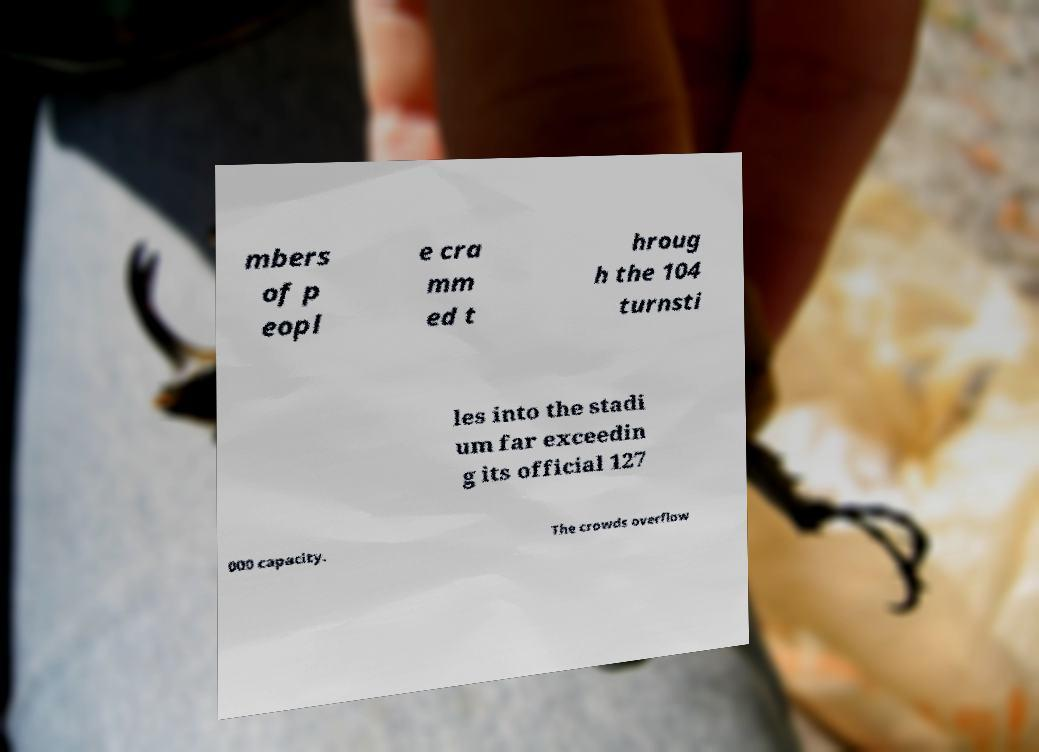Can you read and provide the text displayed in the image?This photo seems to have some interesting text. Can you extract and type it out for me? mbers of p eopl e cra mm ed t hroug h the 104 turnsti les into the stadi um far exceedin g its official 127 000 capacity. The crowds overflow 